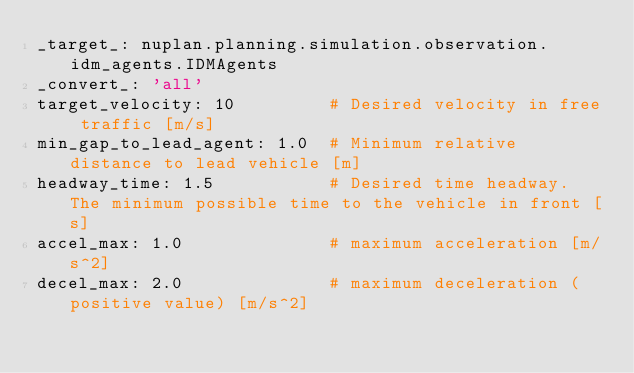<code> <loc_0><loc_0><loc_500><loc_500><_YAML_>_target_: nuplan.planning.simulation.observation.idm_agents.IDMAgents
_convert_: 'all'
target_velocity: 10         # Desired velocity in free traffic [m/s]
min_gap_to_lead_agent: 1.0  # Minimum relative distance to lead vehicle [m]
headway_time: 1.5           # Desired time headway. The minimum possible time to the vehicle in front [s]
accel_max: 1.0              # maximum acceleration [m/s^2]
decel_max: 2.0              # maximum deceleration (positive value) [m/s^2]
</code> 